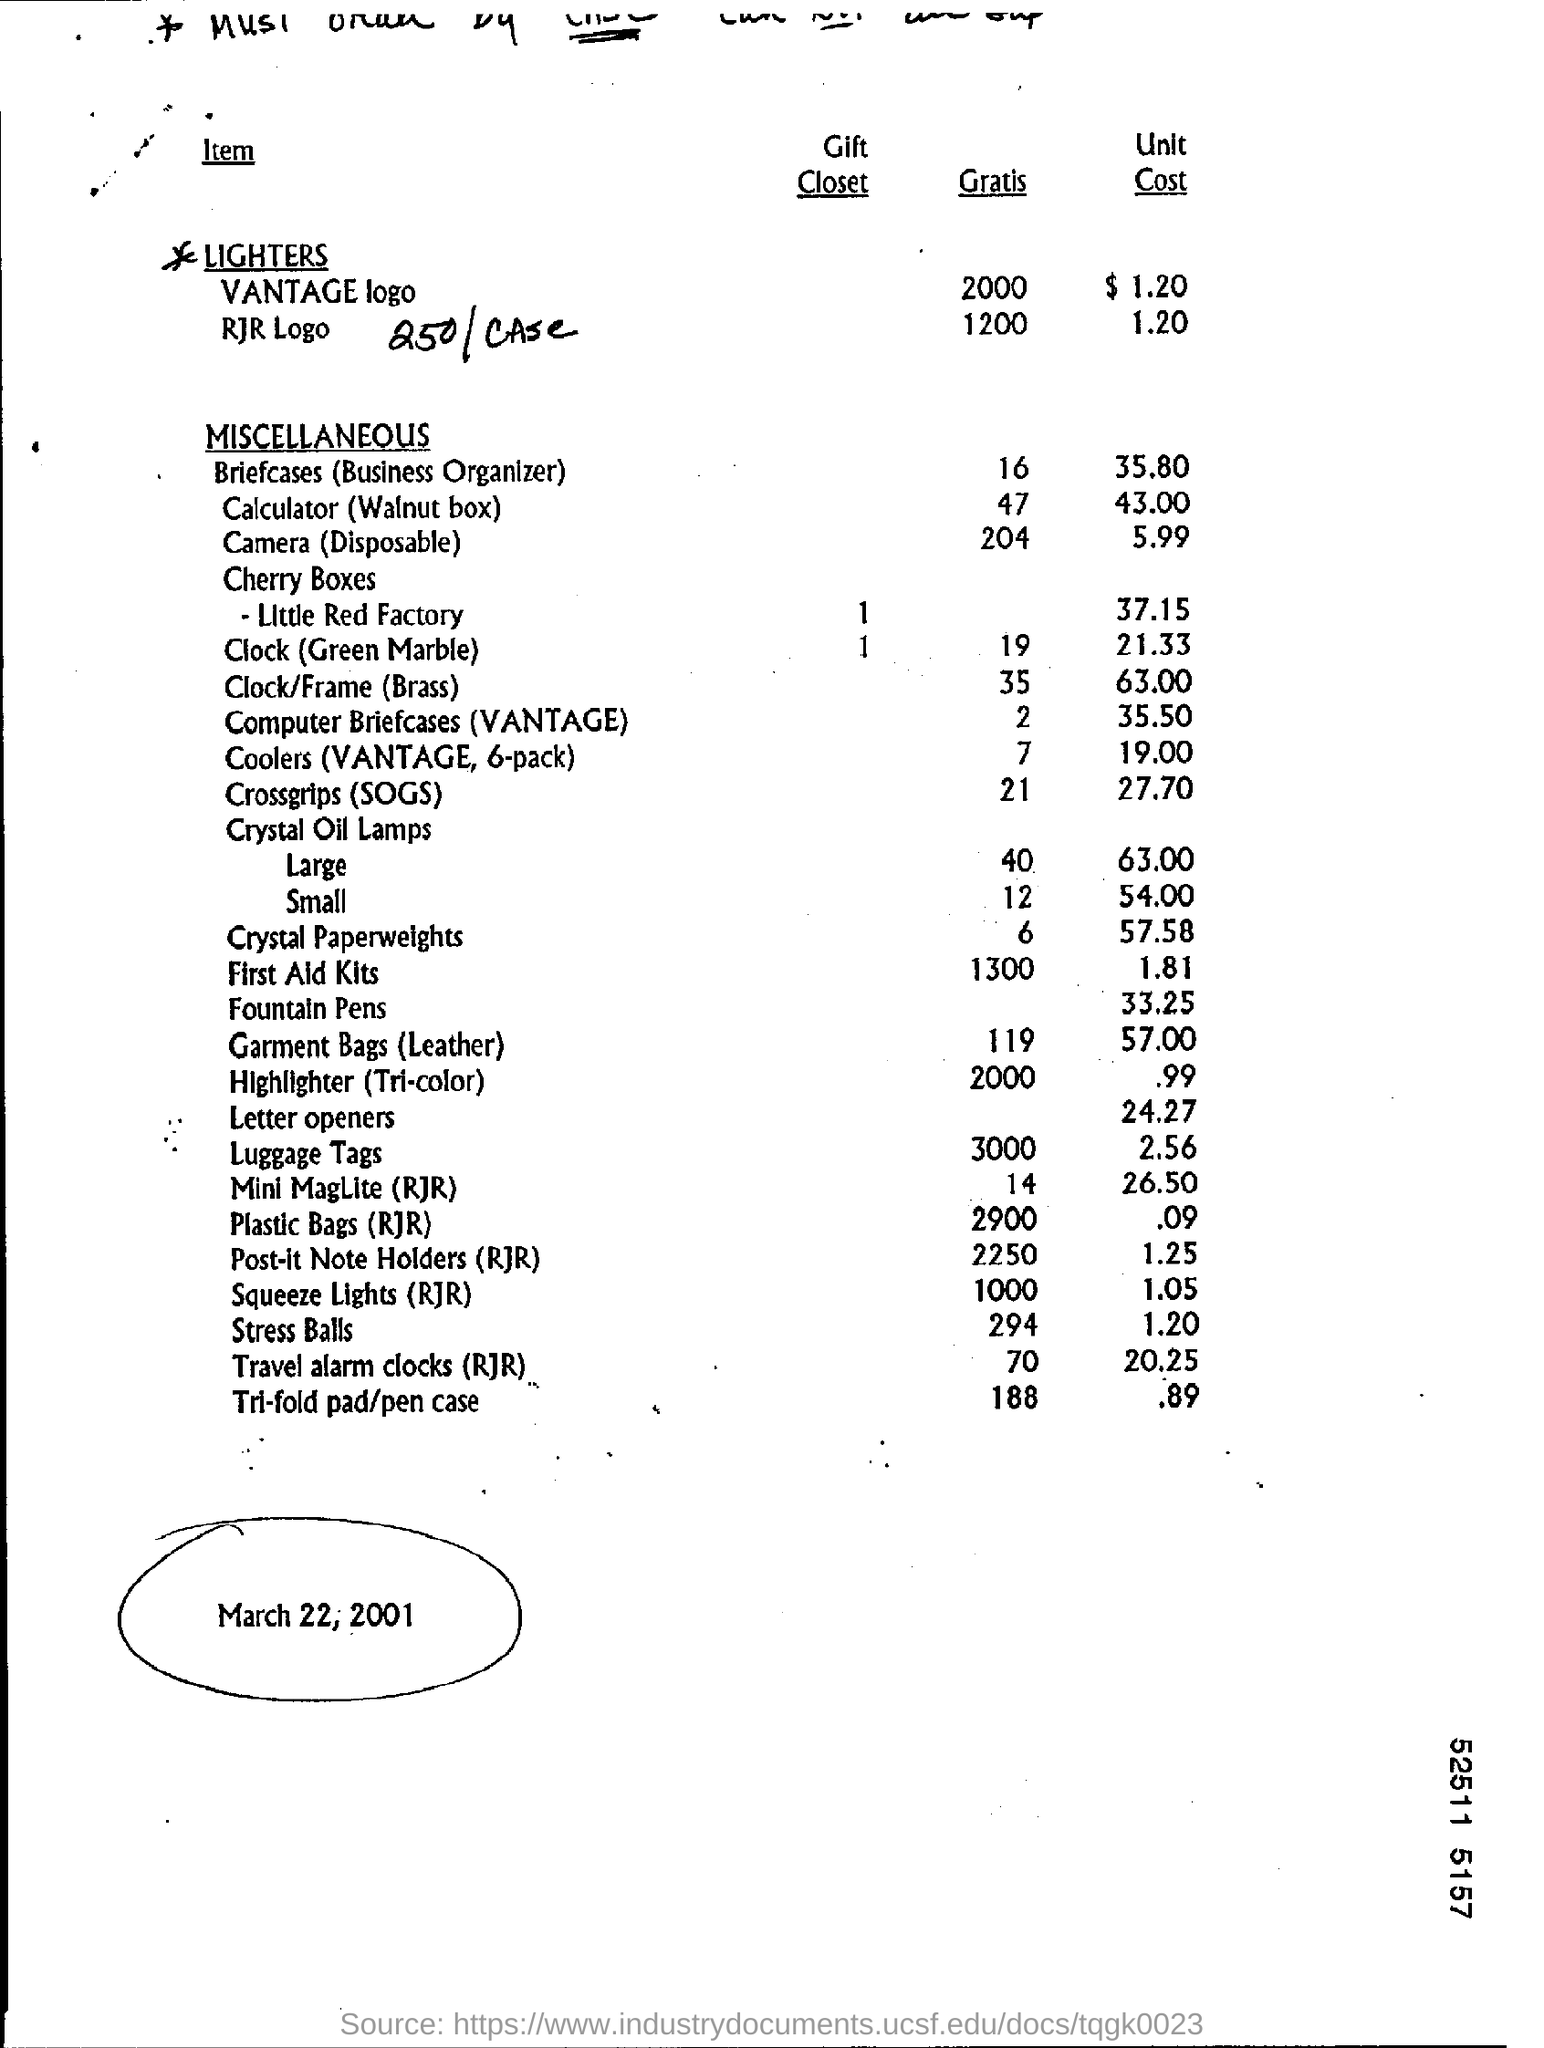Indicate a few pertinent items in this graphic. The briefcase (business organizer) is known as the Gratis. The date mentioned is March 22, 2001. The unit cost of a stress ball is $1.20. The unit cost of plastic bags at RJR is approximately 0.09 cents. 